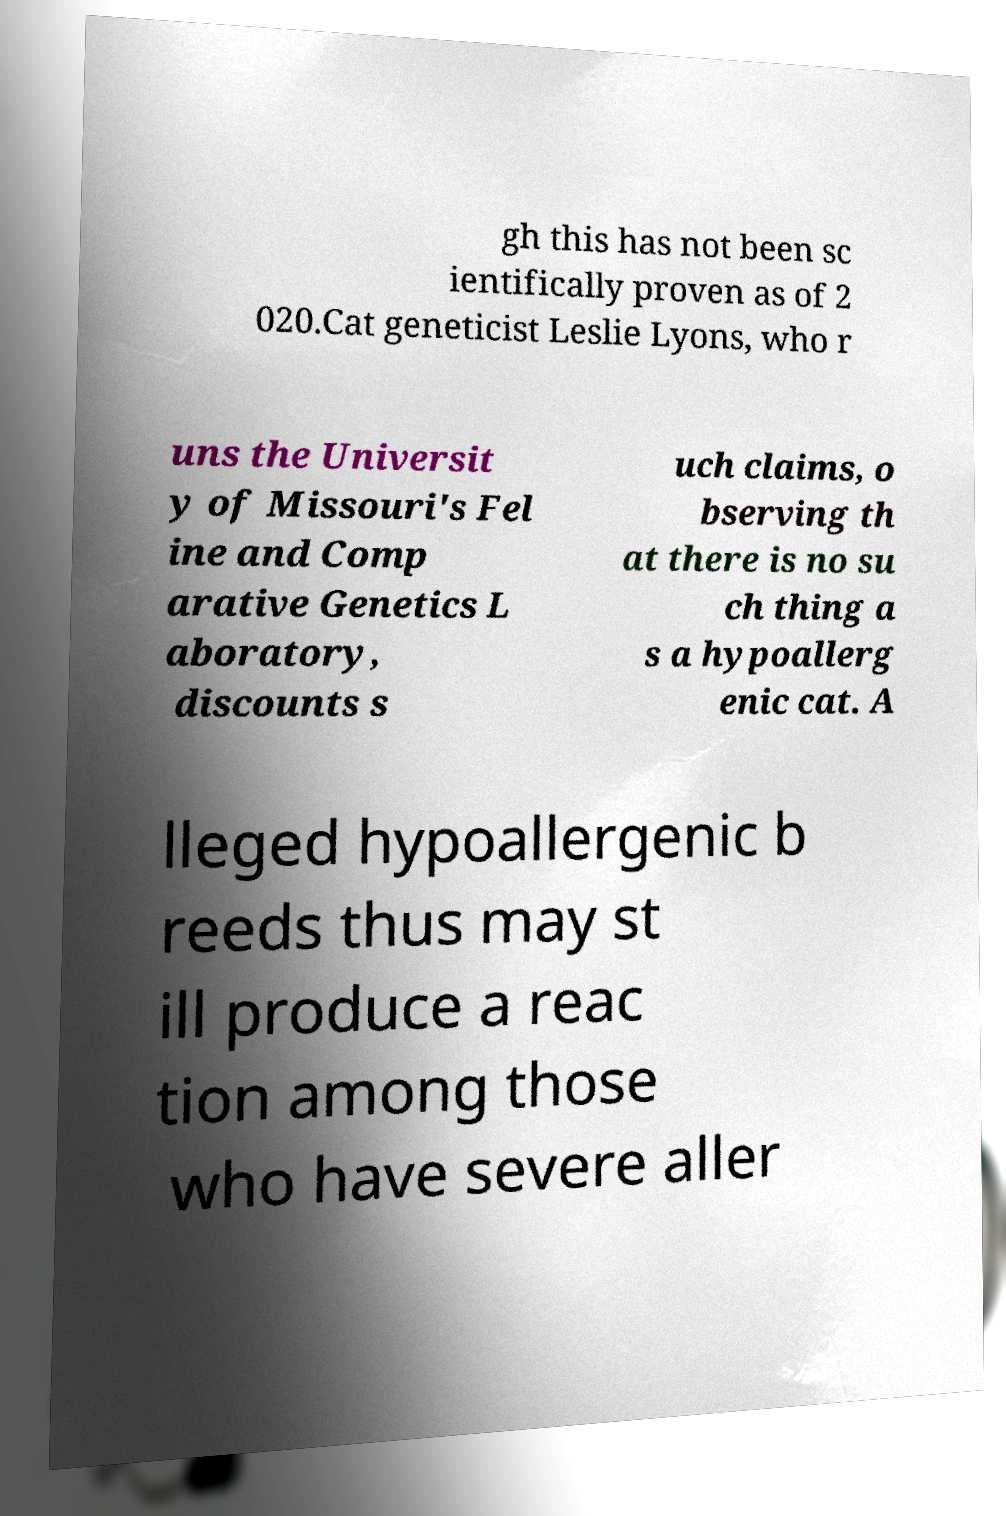What messages or text are displayed in this image? I need them in a readable, typed format. gh this has not been sc ientifically proven as of 2 020.Cat geneticist Leslie Lyons, who r uns the Universit y of Missouri's Fel ine and Comp arative Genetics L aboratory, discounts s uch claims, o bserving th at there is no su ch thing a s a hypoallerg enic cat. A lleged hypoallergenic b reeds thus may st ill produce a reac tion among those who have severe aller 